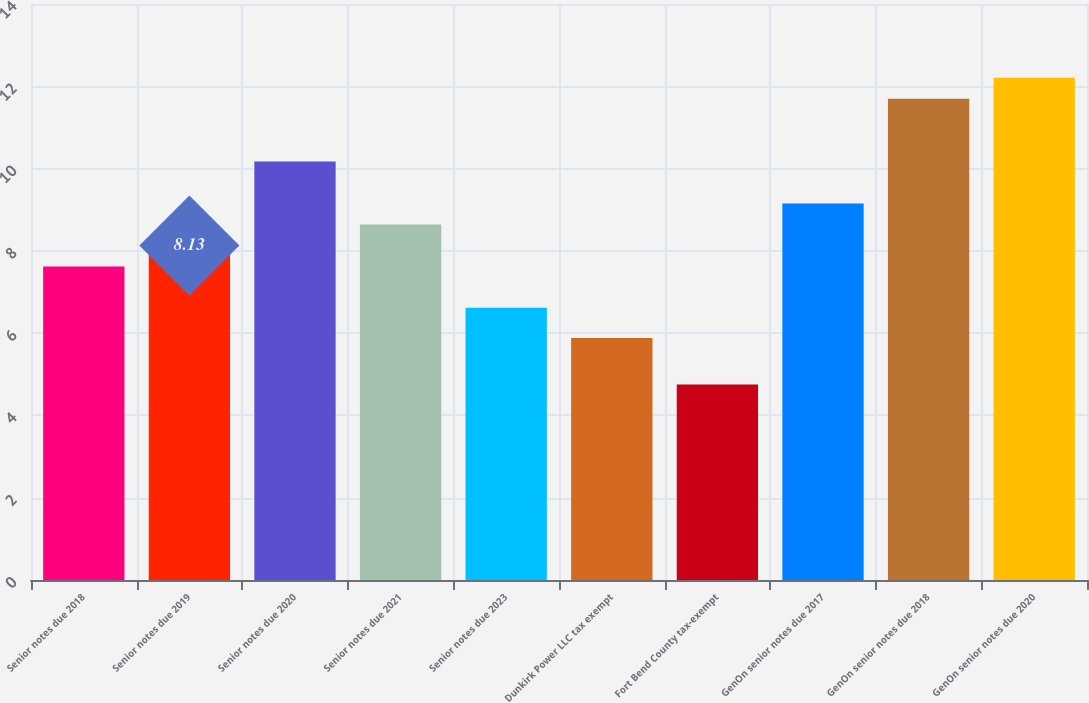Convert chart. <chart><loc_0><loc_0><loc_500><loc_500><bar_chart><fcel>Senior notes due 2018<fcel>Senior notes due 2019<fcel>Senior notes due 2020<fcel>Senior notes due 2021<fcel>Senior notes due 2023<fcel>Dunkirk Power LLC tax exempt<fcel>Fort Bend County tax-exempt<fcel>GenOn senior notes due 2017<fcel>GenOn senior notes due 2018<fcel>GenOn senior notes due 2020<nl><fcel>7.62<fcel>8.13<fcel>10.17<fcel>8.64<fcel>6.62<fcel>5.88<fcel>4.75<fcel>9.15<fcel>11.7<fcel>12.21<nl></chart> 